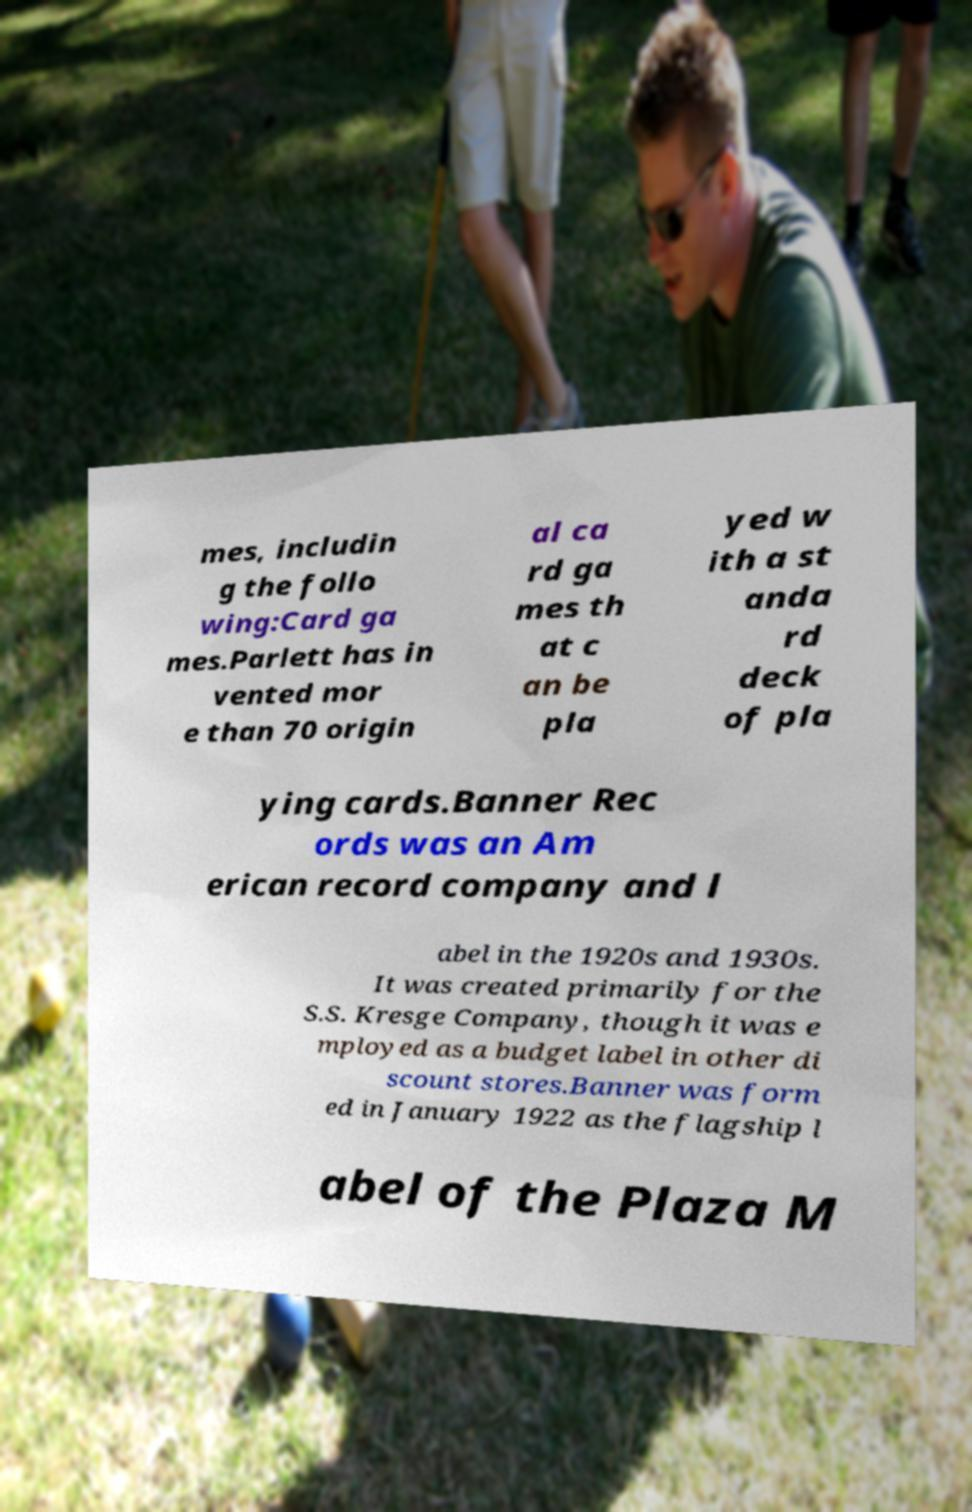Can you accurately transcribe the text from the provided image for me? mes, includin g the follo wing:Card ga mes.Parlett has in vented mor e than 70 origin al ca rd ga mes th at c an be pla yed w ith a st anda rd deck of pla ying cards.Banner Rec ords was an Am erican record company and l abel in the 1920s and 1930s. It was created primarily for the S.S. Kresge Company, though it was e mployed as a budget label in other di scount stores.Banner was form ed in January 1922 as the flagship l abel of the Plaza M 